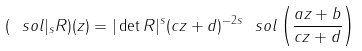Convert formula to latex. <formula><loc_0><loc_0><loc_500><loc_500>( \ s o l | _ { s } R ) ( z ) = | \det R | ^ { s } ( c z + d ) ^ { - 2 s } \ s o l \left ( \frac { a z + b } { c z + d } \right )</formula> 